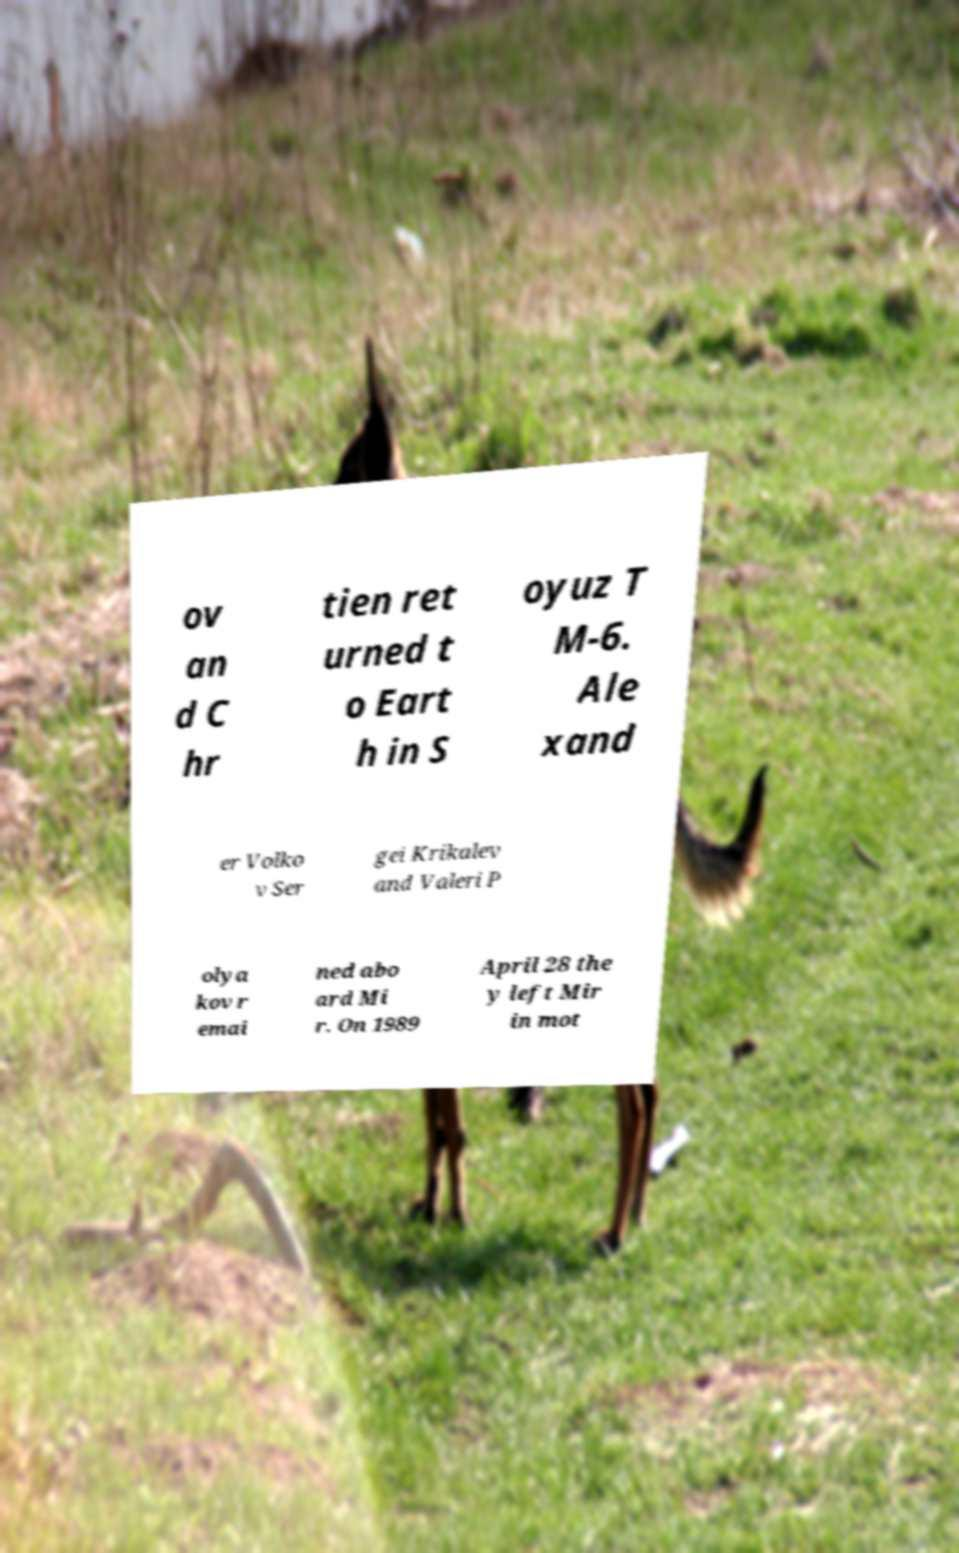I need the written content from this picture converted into text. Can you do that? ov an d C hr tien ret urned t o Eart h in S oyuz T M-6. Ale xand er Volko v Ser gei Krikalev and Valeri P olya kov r emai ned abo ard Mi r. On 1989 April 28 the y left Mir in mot 